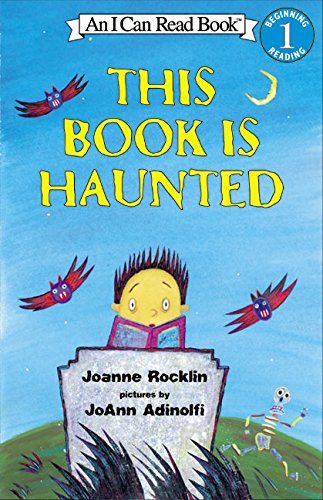Who is the author of this book? The author of 'This Book is Haunted' is Joanne Rocklin, an acclaimed writer known for her engaging children's literature. 